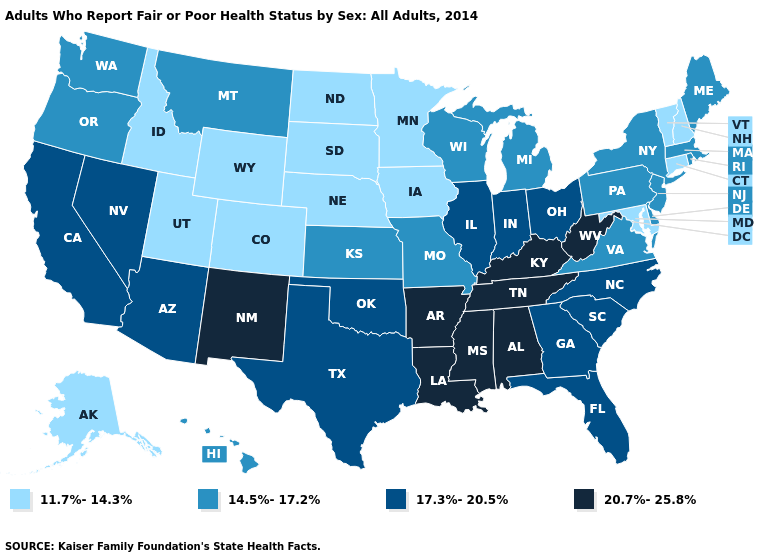How many symbols are there in the legend?
Give a very brief answer. 4. Does Alabama have the lowest value in the USA?
Give a very brief answer. No. Does the first symbol in the legend represent the smallest category?
Give a very brief answer. Yes. Which states hav the highest value in the Northeast?
Write a very short answer. Maine, Massachusetts, New Jersey, New York, Pennsylvania, Rhode Island. Does Maine have the same value as Indiana?
Short answer required. No. Name the states that have a value in the range 17.3%-20.5%?
Write a very short answer. Arizona, California, Florida, Georgia, Illinois, Indiana, Nevada, North Carolina, Ohio, Oklahoma, South Carolina, Texas. What is the value of New York?
Give a very brief answer. 14.5%-17.2%. What is the highest value in the USA?
Write a very short answer. 20.7%-25.8%. Among the states that border Indiana , which have the lowest value?
Write a very short answer. Michigan. Which states have the highest value in the USA?
Be succinct. Alabama, Arkansas, Kentucky, Louisiana, Mississippi, New Mexico, Tennessee, West Virginia. What is the lowest value in states that border Connecticut?
Write a very short answer. 14.5%-17.2%. Name the states that have a value in the range 11.7%-14.3%?
Be succinct. Alaska, Colorado, Connecticut, Idaho, Iowa, Maryland, Minnesota, Nebraska, New Hampshire, North Dakota, South Dakota, Utah, Vermont, Wyoming. What is the lowest value in the USA?
Give a very brief answer. 11.7%-14.3%. Does Rhode Island have the lowest value in the Northeast?
Concise answer only. No. 